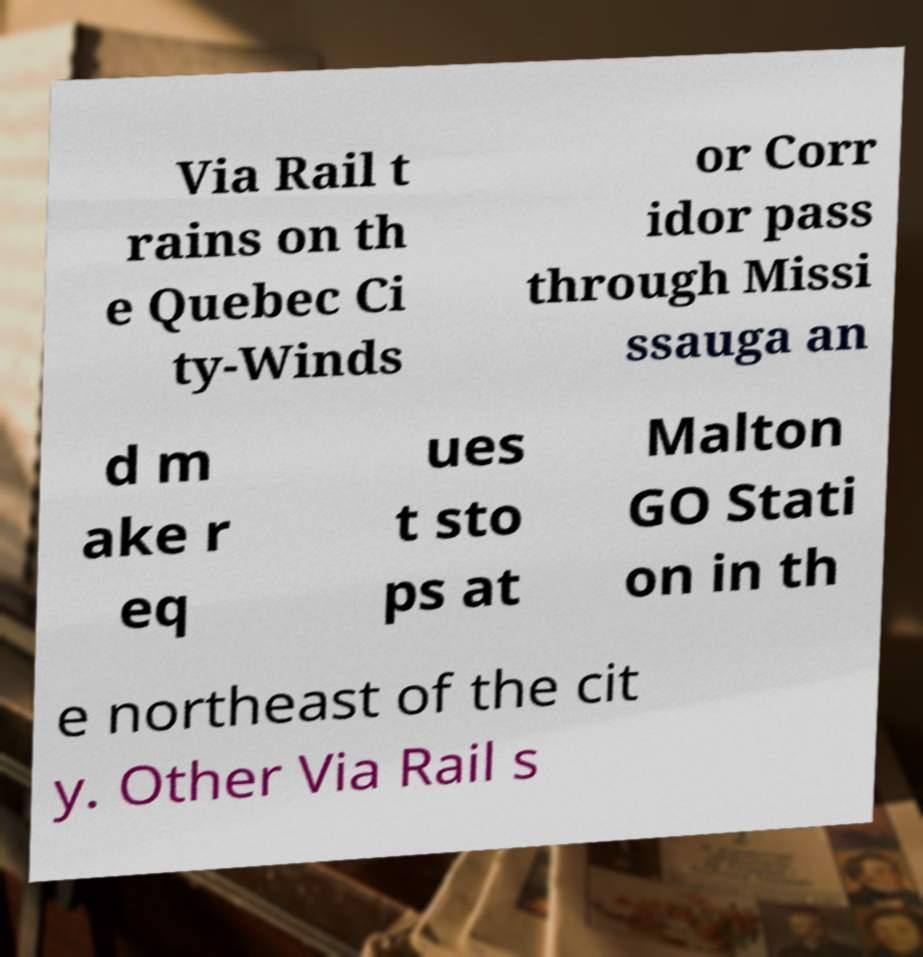What messages or text are displayed in this image? I need them in a readable, typed format. Via Rail t rains on th e Quebec Ci ty-Winds or Corr idor pass through Missi ssauga an d m ake r eq ues t sto ps at Malton GO Stati on in th e northeast of the cit y. Other Via Rail s 